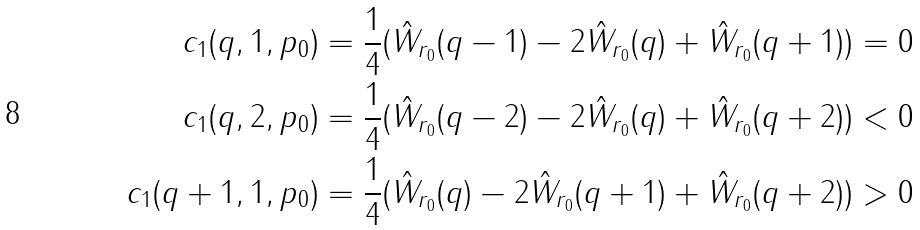<formula> <loc_0><loc_0><loc_500><loc_500>c _ { 1 } ( q , 1 , p _ { 0 } ) & = \frac { 1 } { 4 } ( \hat { W } _ { r _ { 0 } } ( q - 1 ) - 2 \hat { W } _ { r _ { 0 } } ( q ) + \hat { W } _ { r _ { 0 } } ( q + 1 ) ) = 0 \\ c _ { 1 } ( q , 2 , p _ { 0 } ) & = \frac { 1 } { 4 } ( \hat { W } _ { r _ { 0 } } ( q - 2 ) - 2 \hat { W } _ { r _ { 0 } } ( q ) + \hat { W } _ { r _ { 0 } } ( q + 2 ) ) < 0 \\ c _ { 1 } ( q + 1 , 1 , p _ { 0 } ) & = \frac { 1 } { 4 } ( \hat { W } _ { r _ { 0 } } ( q ) - 2 \hat { W } _ { r _ { 0 } } ( q + 1 ) + \hat { W } _ { r _ { 0 } } ( q + 2 ) ) > 0</formula> 